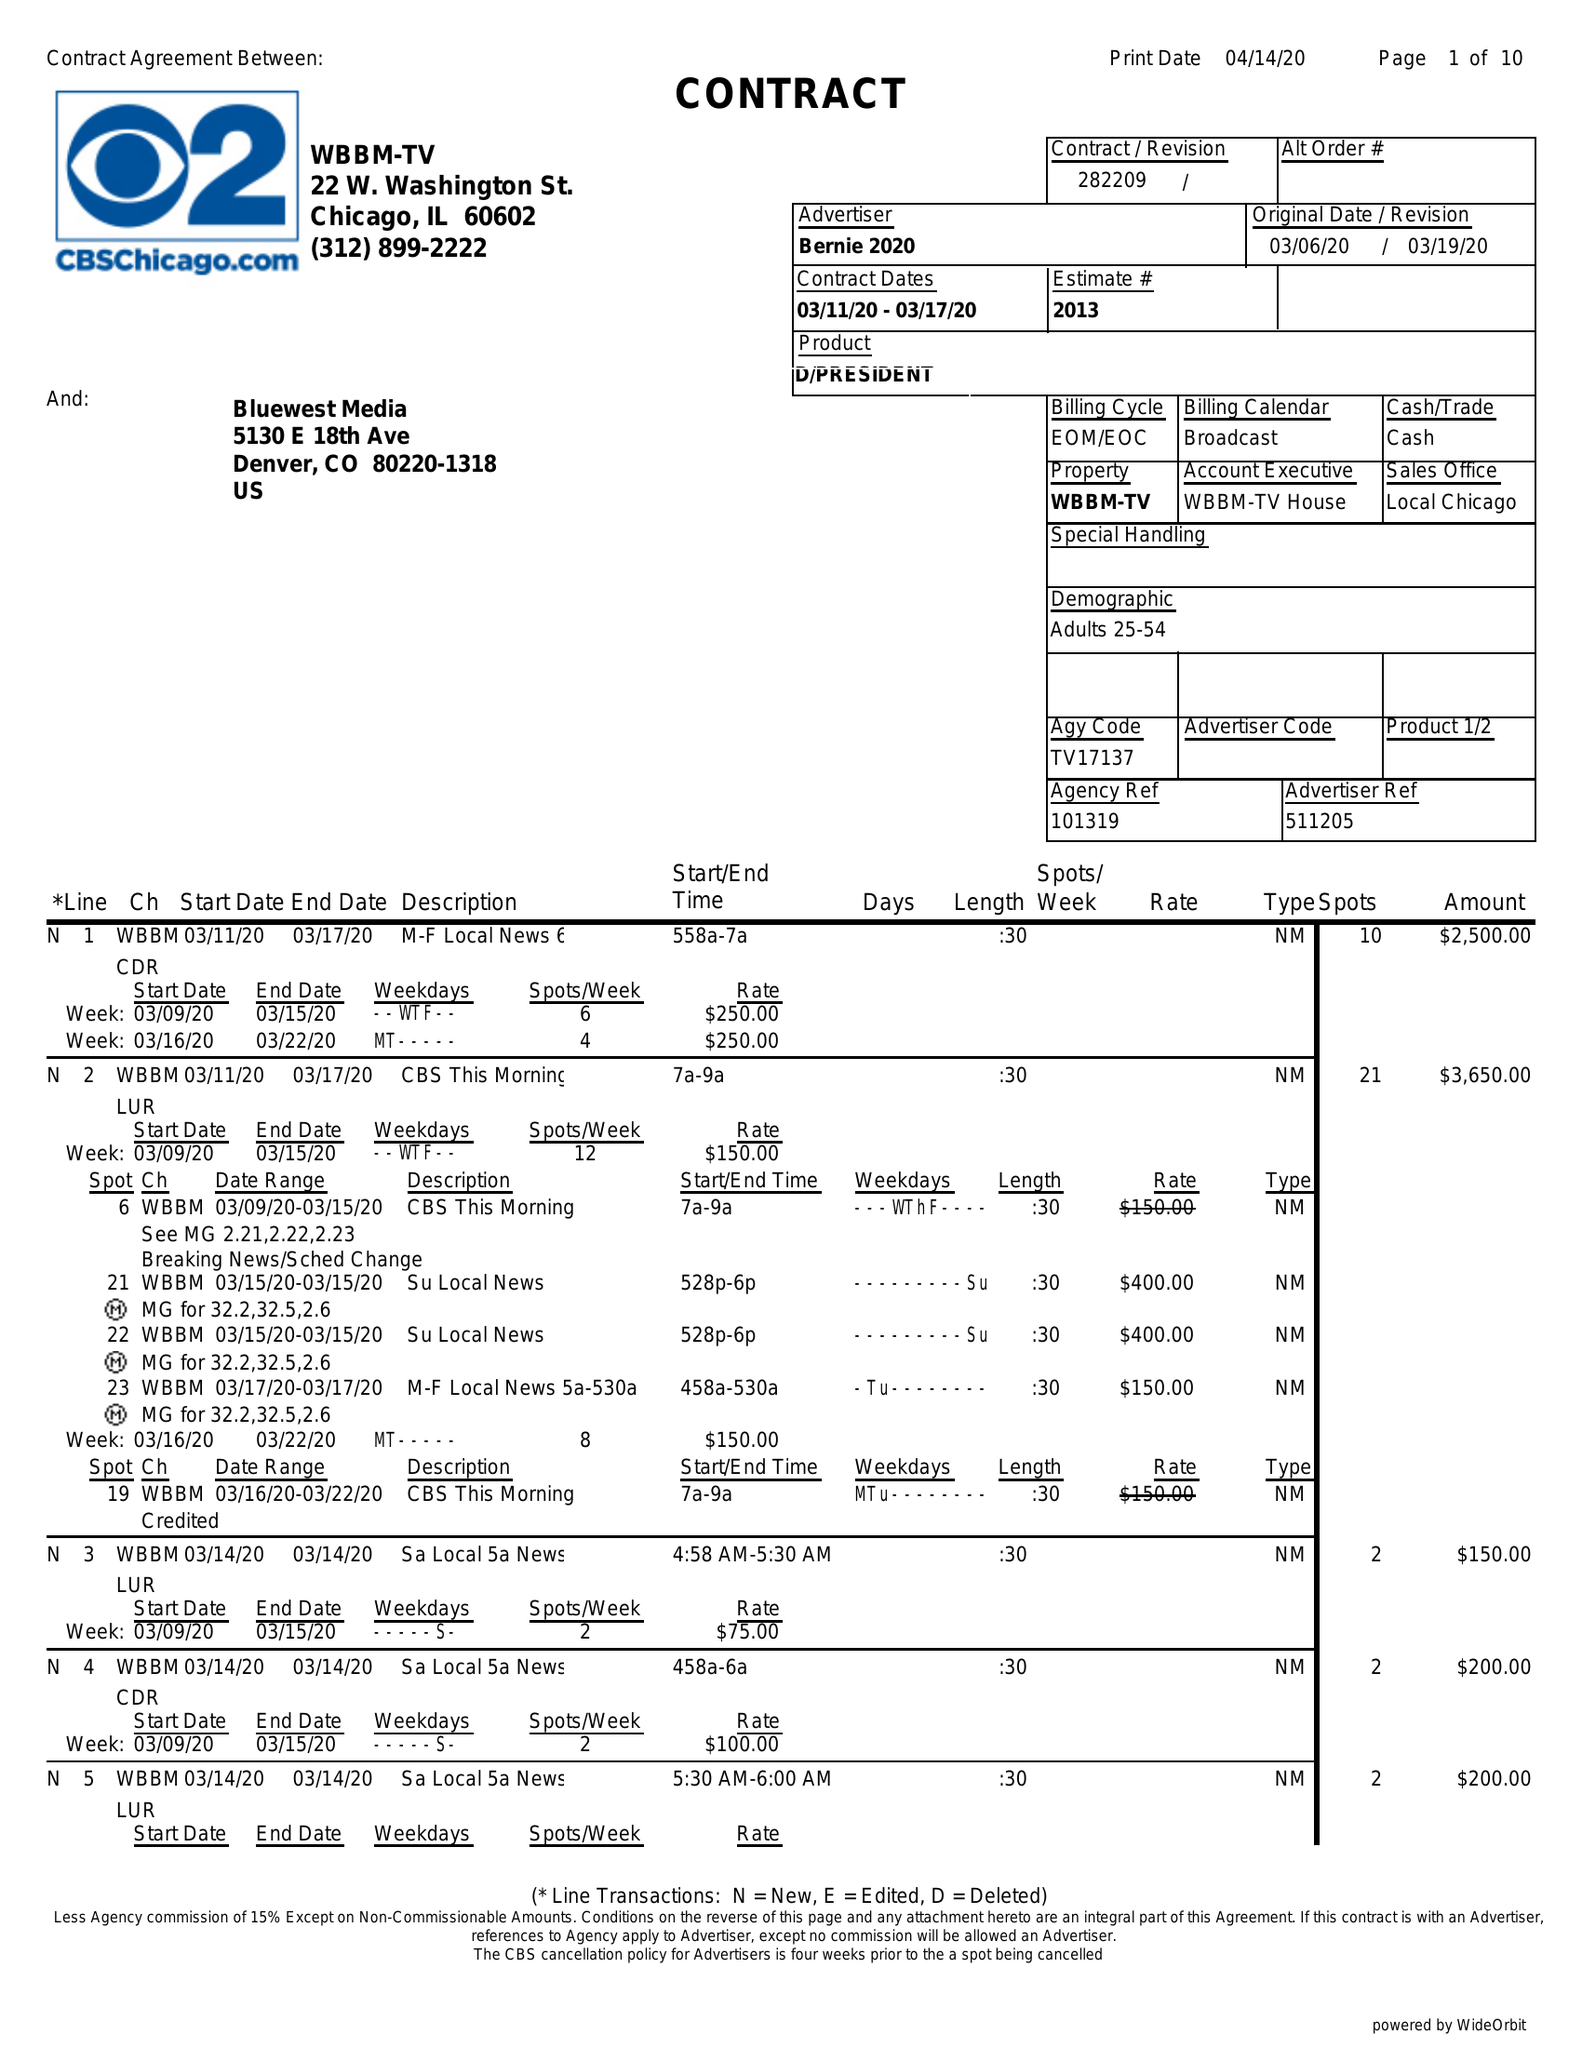What is the value for the flight_from?
Answer the question using a single word or phrase. 03/11/20 